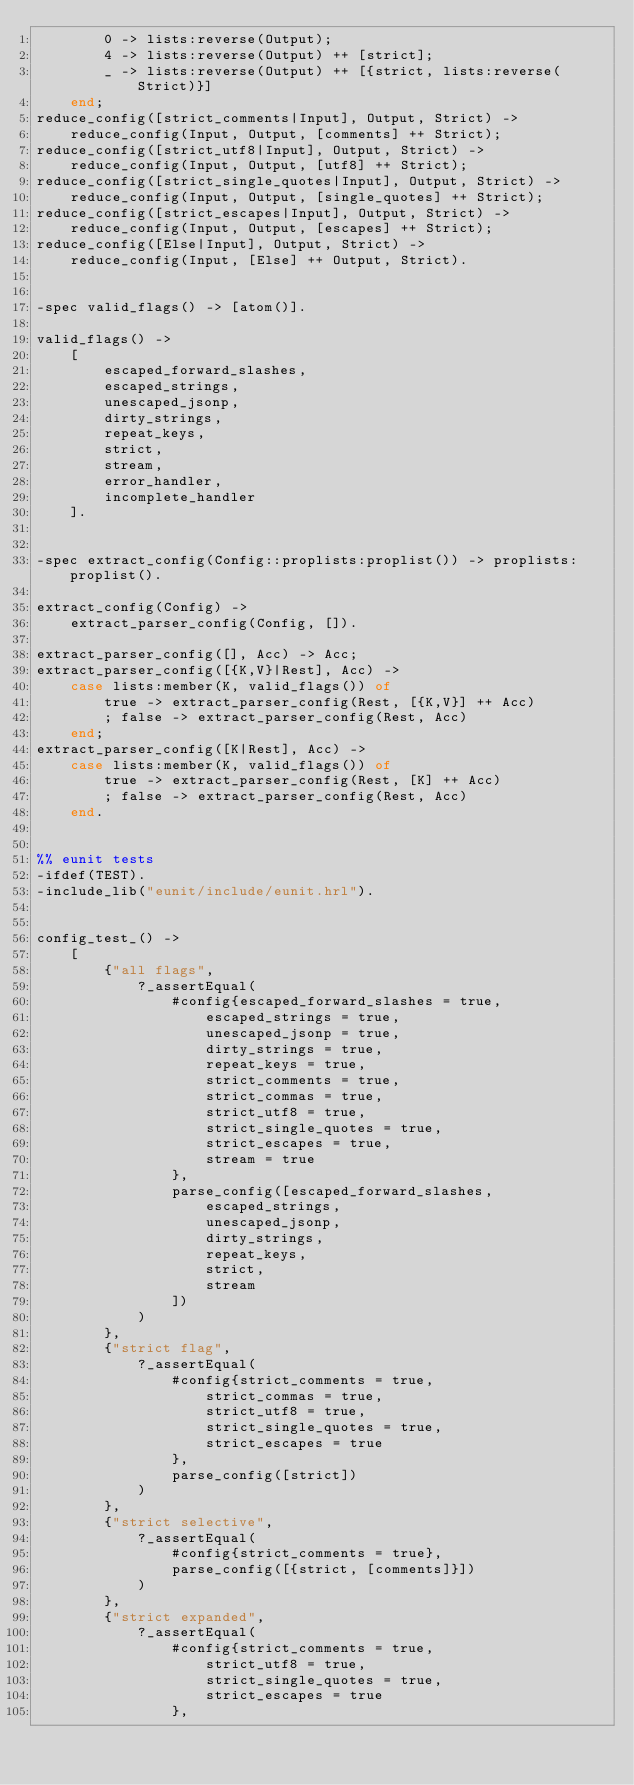<code> <loc_0><loc_0><loc_500><loc_500><_Erlang_>        0 -> lists:reverse(Output);
        4 -> lists:reverse(Output) ++ [strict];
        _ -> lists:reverse(Output) ++ [{strict, lists:reverse(Strict)}]
    end;
reduce_config([strict_comments|Input], Output, Strict) ->
    reduce_config(Input, Output, [comments] ++ Strict);
reduce_config([strict_utf8|Input], Output, Strict) ->
    reduce_config(Input, Output, [utf8] ++ Strict);
reduce_config([strict_single_quotes|Input], Output, Strict) ->
    reduce_config(Input, Output, [single_quotes] ++ Strict);
reduce_config([strict_escapes|Input], Output, Strict) ->
    reduce_config(Input, Output, [escapes] ++ Strict);
reduce_config([Else|Input], Output, Strict) ->
    reduce_config(Input, [Else] ++ Output, Strict).


-spec valid_flags() -> [atom()].

valid_flags() ->
    [
        escaped_forward_slashes,
        escaped_strings,
        unescaped_jsonp,
        dirty_strings,
        repeat_keys,
        strict,
        stream,
        error_handler,
        incomplete_handler
    ].


-spec extract_config(Config::proplists:proplist()) -> proplists:proplist().

extract_config(Config) ->
    extract_parser_config(Config, []).

extract_parser_config([], Acc) -> Acc;
extract_parser_config([{K,V}|Rest], Acc) ->
    case lists:member(K, valid_flags()) of
        true -> extract_parser_config(Rest, [{K,V}] ++ Acc)
        ; false -> extract_parser_config(Rest, Acc)
    end;
extract_parser_config([K|Rest], Acc) ->
    case lists:member(K, valid_flags()) of
        true -> extract_parser_config(Rest, [K] ++ Acc)
        ; false -> extract_parser_config(Rest, Acc)
    end.


%% eunit tests
-ifdef(TEST).
-include_lib("eunit/include/eunit.hrl").


config_test_() ->
    [
        {"all flags",
            ?_assertEqual(
                #config{escaped_forward_slashes = true,
                    escaped_strings = true,
                    unescaped_jsonp = true,
                    dirty_strings = true,
                    repeat_keys = true,
                    strict_comments = true,
                    strict_commas = true,
                    strict_utf8 = true,
                    strict_single_quotes = true,
                    strict_escapes = true,
                    stream = true
                },
                parse_config([escaped_forward_slashes,
                    escaped_strings,
                    unescaped_jsonp,
                    dirty_strings,
                    repeat_keys,
                    strict,
                    stream
                ])
            )
        },
        {"strict flag",
            ?_assertEqual(
                #config{strict_comments = true,
                    strict_commas = true,
                    strict_utf8 = true,
                    strict_single_quotes = true,
                    strict_escapes = true
                },
                parse_config([strict])
            )
        },
        {"strict selective",
            ?_assertEqual(
                #config{strict_comments = true},
                parse_config([{strict, [comments]}])
            )
        },
        {"strict expanded",
            ?_assertEqual(
                #config{strict_comments = true,
                    strict_utf8 = true,
                    strict_single_quotes = true,
                    strict_escapes = true
                },</code> 